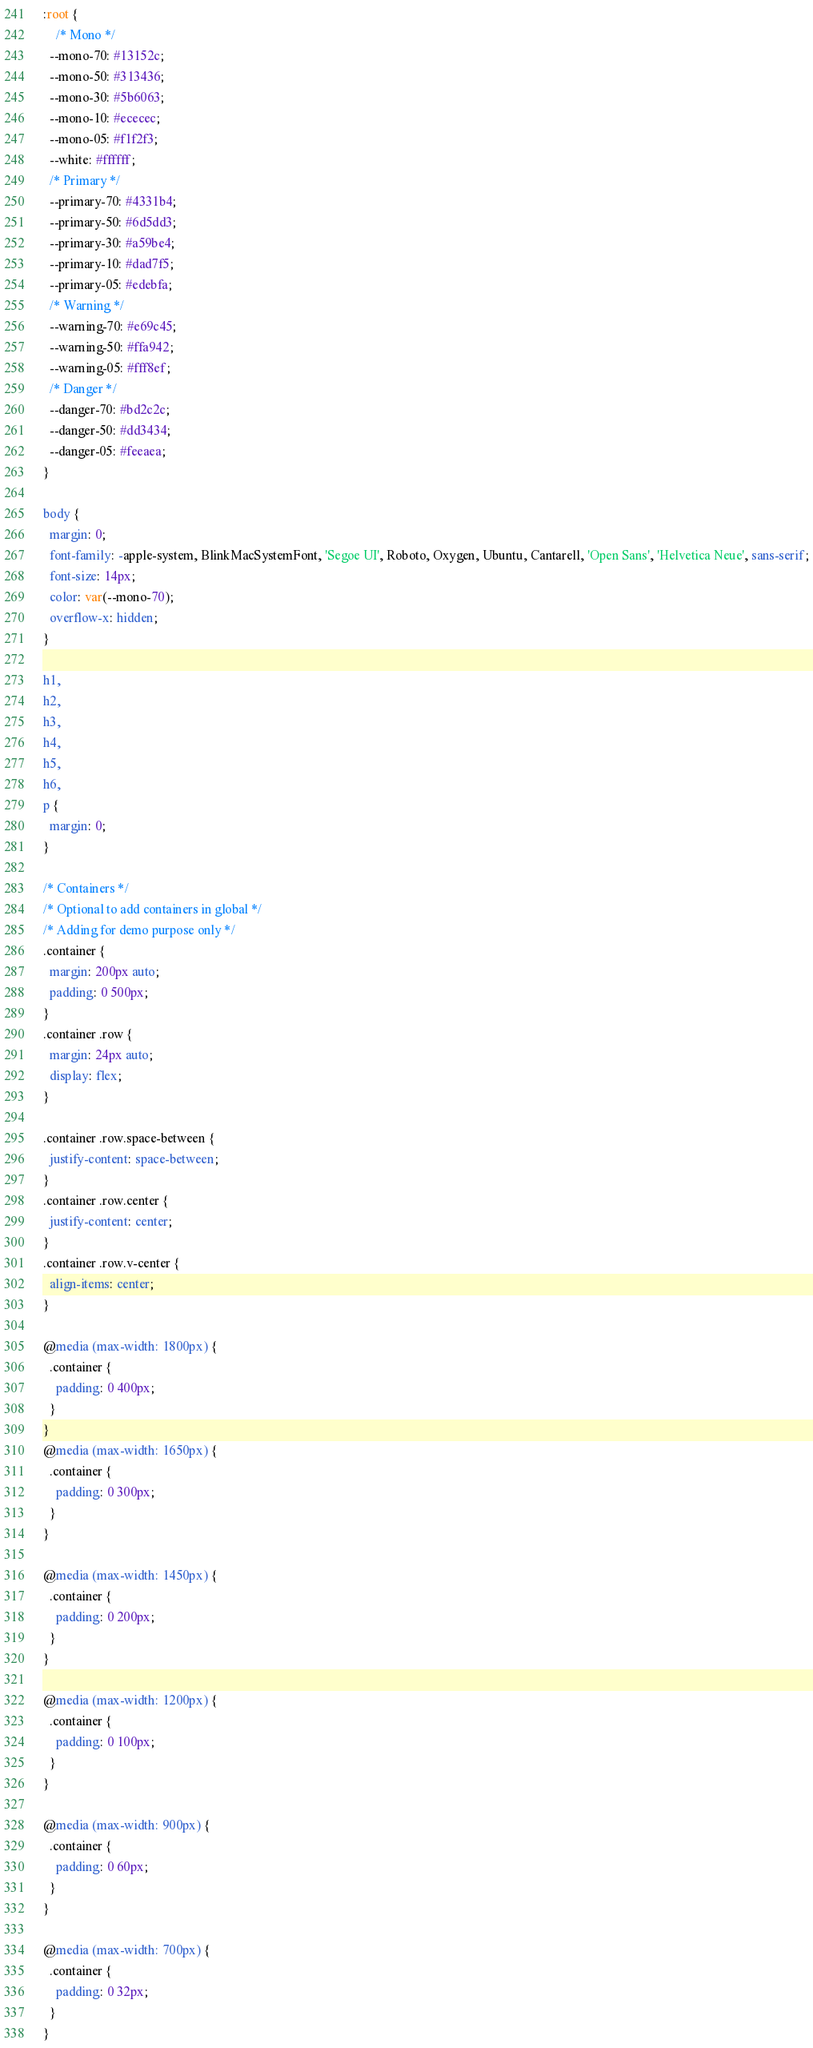<code> <loc_0><loc_0><loc_500><loc_500><_CSS_>:root {
    /* Mono */
  --mono-70: #13152c;
  --mono-50: #313436;
  --mono-30: #5b6063;
  --mono-10: #ececec;
  --mono-05: #f1f2f3;
  --white: #ffffff;
  /* Primary */
  --primary-70: #4331b4;
  --primary-50: #6d5dd3;
  --primary-30: #a59be4;
  --primary-10: #dad7f5;
  --primary-05: #edebfa;
  /* Warning */
  --warning-70: #e69c45;
  --warning-50: #ffa942;
  --warning-05: #fff8ef;
  /* Danger */
  --danger-70: #bd2c2c;
  --danger-50: #dd3434;
  --danger-05: #feeaea;
}

body {
  margin: 0;
  font-family: -apple-system, BlinkMacSystemFont, 'Segoe UI', Roboto, Oxygen, Ubuntu, Cantarell, 'Open Sans', 'Helvetica Neue', sans-serif;
  font-size: 14px;
  color: var(--mono-70);
  overflow-x: hidden;
}

h1,
h2,
h3,
h4,
h5,
h6,
p {
  margin: 0;
}

/* Containers */
/* Optional to add containers in global */
/* Adding for demo purpose only */
.container {
  margin: 200px auto;
  padding: 0 500px;
}
.container .row {
  margin: 24px auto;
  display: flex;
}

.container .row.space-between {
  justify-content: space-between;
}
.container .row.center {
  justify-content: center;
}
.container .row.v-center {
  align-items: center;
}

@media (max-width: 1800px) {
  .container {
    padding: 0 400px;
  }
}
@media (max-width: 1650px) {
  .container {
    padding: 0 300px;
  }
}

@media (max-width: 1450px) {
  .container {
    padding: 0 200px;
  }
}

@media (max-width: 1200px) {
  .container {
    padding: 0 100px;
  }
}

@media (max-width: 900px) {
  .container {
    padding: 0 60px;
  }
}

@media (max-width: 700px) {
  .container {
    padding: 0 32px;
  }
}</code> 